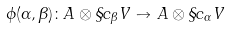Convert formula to latex. <formula><loc_0><loc_0><loc_500><loc_500>\phi ( \alpha , \beta ) \colon A \otimes \S c _ { \beta } V \to A \otimes \S c _ { \alpha } V</formula> 